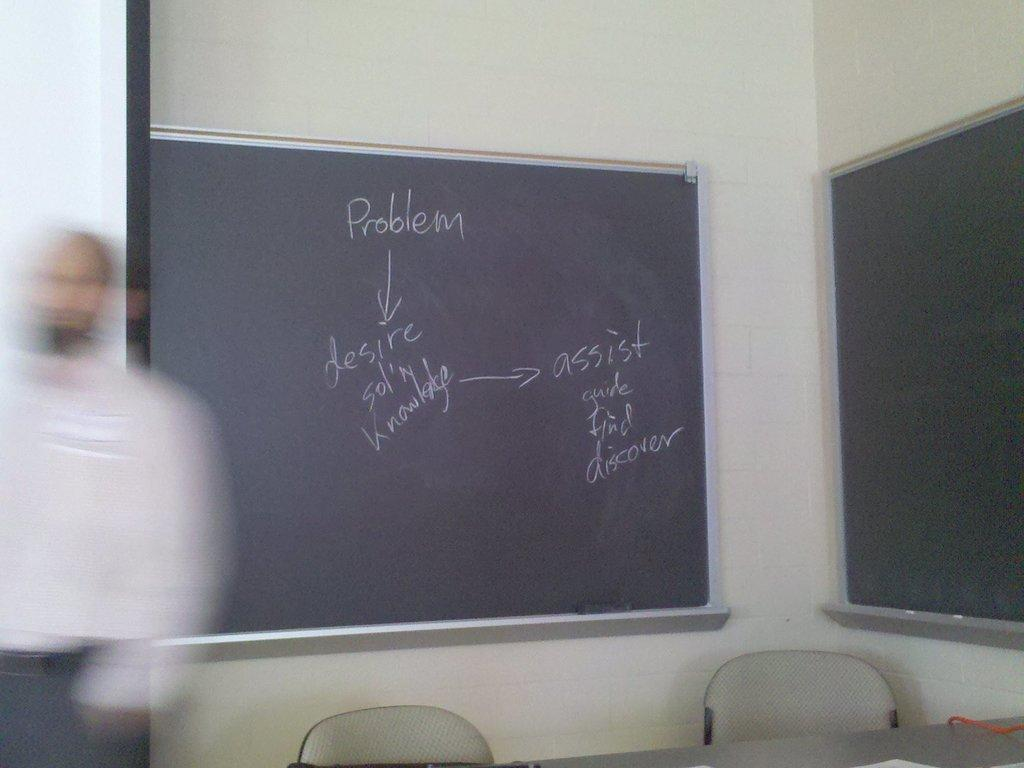What is the main object in the middle of the image? There is a board in the middle of the image. Can you describe the image on the left side of the image? There is a blurred image of a person on the left side of the image. What type of furniture is visible at the bottom of the image? Chairs are present at the bottom of the image. How many spiders are crawling on the board in the image? There are no spiders present in the image; it only features a board, a blurred image of a person, and chairs. What type of verse is written on the board in the image? There is no verse written on the board in the image; it is a plain board with no text or writing. 